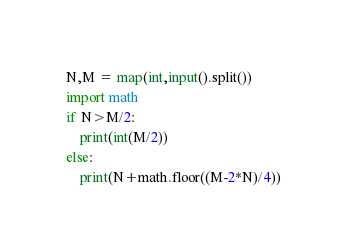Convert code to text. <code><loc_0><loc_0><loc_500><loc_500><_Python_>N,M = map(int,input().split())
import math
if N>M/2:
    print(int(M/2))
else:
    print(N+math.floor((M-2*N)/4))</code> 